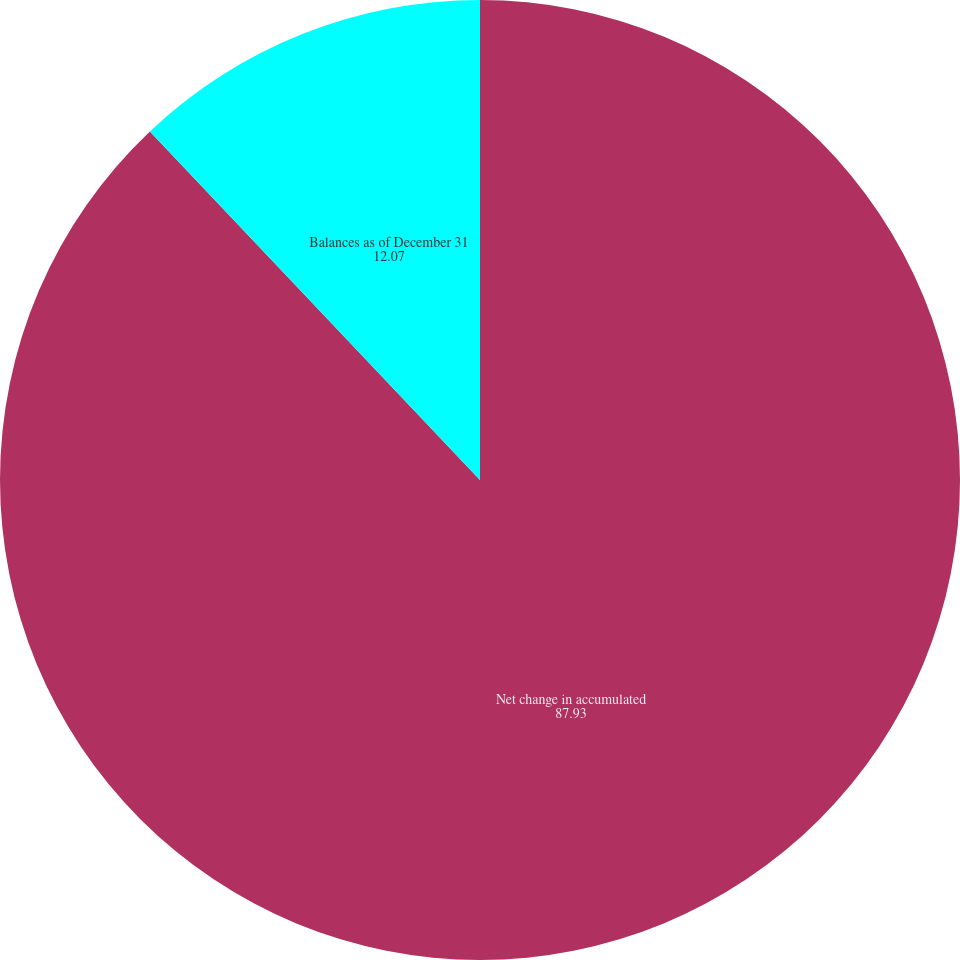Convert chart to OTSL. <chart><loc_0><loc_0><loc_500><loc_500><pie_chart><fcel>Net change in accumulated<fcel>Balances as of December 31<nl><fcel>87.93%<fcel>12.07%<nl></chart> 